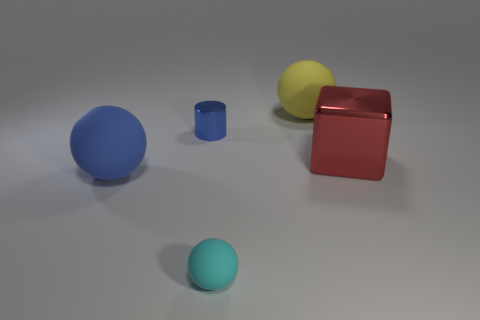Add 1 large yellow objects. How many objects exist? 6 Subtract all green cylinders. Subtract all green blocks. How many cylinders are left? 1 Subtract all cylinders. How many objects are left? 4 Subtract 0 green blocks. How many objects are left? 5 Subtract all red things. Subtract all big matte spheres. How many objects are left? 2 Add 2 blue cylinders. How many blue cylinders are left? 3 Add 2 cylinders. How many cylinders exist? 3 